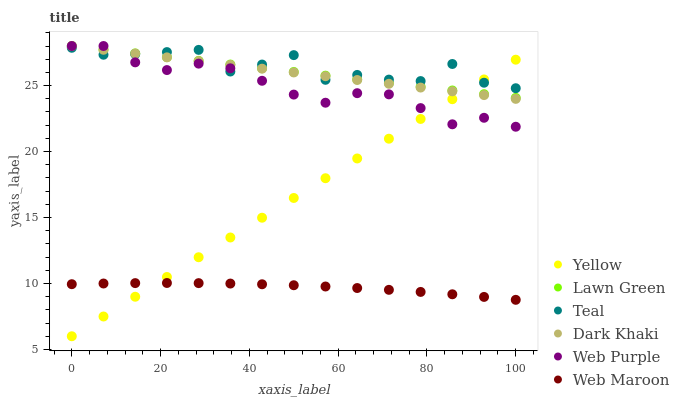Does Web Maroon have the minimum area under the curve?
Answer yes or no. Yes. Does Teal have the maximum area under the curve?
Answer yes or no. Yes. Does Yellow have the minimum area under the curve?
Answer yes or no. No. Does Yellow have the maximum area under the curve?
Answer yes or no. No. Is Lawn Green the smoothest?
Answer yes or no. Yes. Is Teal the roughest?
Answer yes or no. Yes. Is Web Maroon the smoothest?
Answer yes or no. No. Is Web Maroon the roughest?
Answer yes or no. No. Does Yellow have the lowest value?
Answer yes or no. Yes. Does Web Maroon have the lowest value?
Answer yes or no. No. Does Web Purple have the highest value?
Answer yes or no. Yes. Does Yellow have the highest value?
Answer yes or no. No. Is Web Maroon less than Web Purple?
Answer yes or no. Yes. Is Web Purple greater than Web Maroon?
Answer yes or no. Yes. Does Teal intersect Yellow?
Answer yes or no. Yes. Is Teal less than Yellow?
Answer yes or no. No. Is Teal greater than Yellow?
Answer yes or no. No. Does Web Maroon intersect Web Purple?
Answer yes or no. No. 